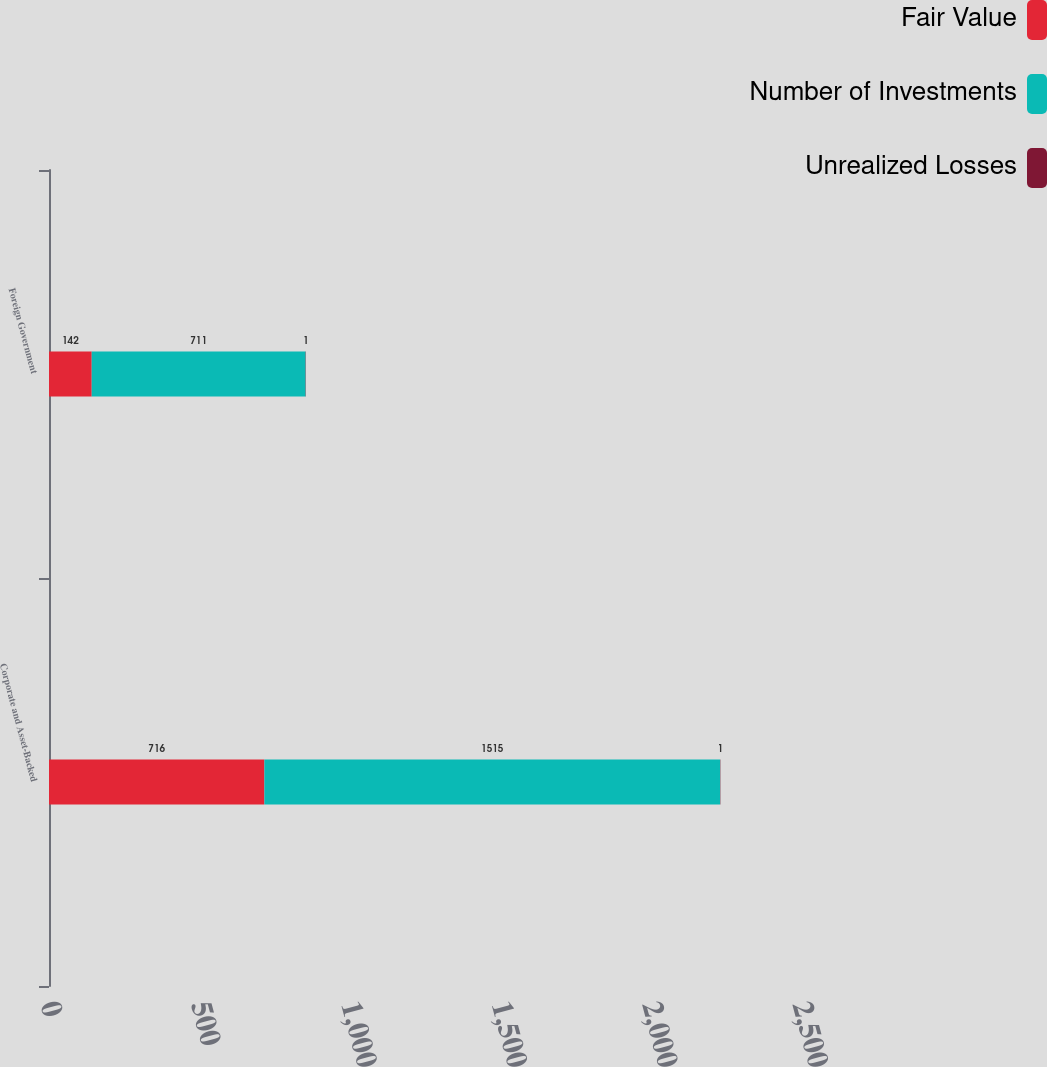Convert chart to OTSL. <chart><loc_0><loc_0><loc_500><loc_500><stacked_bar_chart><ecel><fcel>Corporate and Asset-Backed<fcel>Foreign Government<nl><fcel>Fair Value<fcel>716<fcel>142<nl><fcel>Number of Investments<fcel>1515<fcel>711<nl><fcel>Unrealized Losses<fcel>1<fcel>1<nl></chart> 